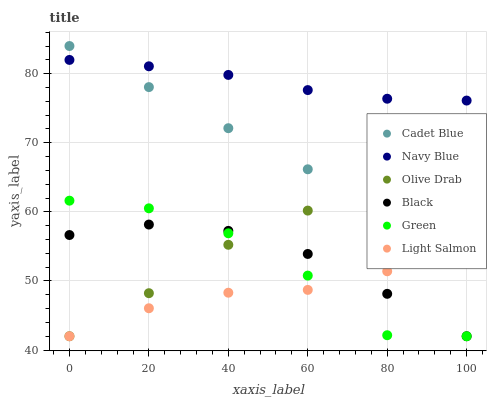Does Light Salmon have the minimum area under the curve?
Answer yes or no. Yes. Does Navy Blue have the maximum area under the curve?
Answer yes or no. Yes. Does Cadet Blue have the minimum area under the curve?
Answer yes or no. No. Does Cadet Blue have the maximum area under the curve?
Answer yes or no. No. Is Cadet Blue the smoothest?
Answer yes or no. Yes. Is Green the roughest?
Answer yes or no. Yes. Is Navy Blue the smoothest?
Answer yes or no. No. Is Navy Blue the roughest?
Answer yes or no. No. Does Light Salmon have the lowest value?
Answer yes or no. Yes. Does Cadet Blue have the lowest value?
Answer yes or no. No. Does Cadet Blue have the highest value?
Answer yes or no. Yes. Does Navy Blue have the highest value?
Answer yes or no. No. Is Olive Drab less than Navy Blue?
Answer yes or no. Yes. Is Navy Blue greater than Light Salmon?
Answer yes or no. Yes. Does Black intersect Green?
Answer yes or no. Yes. Is Black less than Green?
Answer yes or no. No. Is Black greater than Green?
Answer yes or no. No. Does Olive Drab intersect Navy Blue?
Answer yes or no. No. 